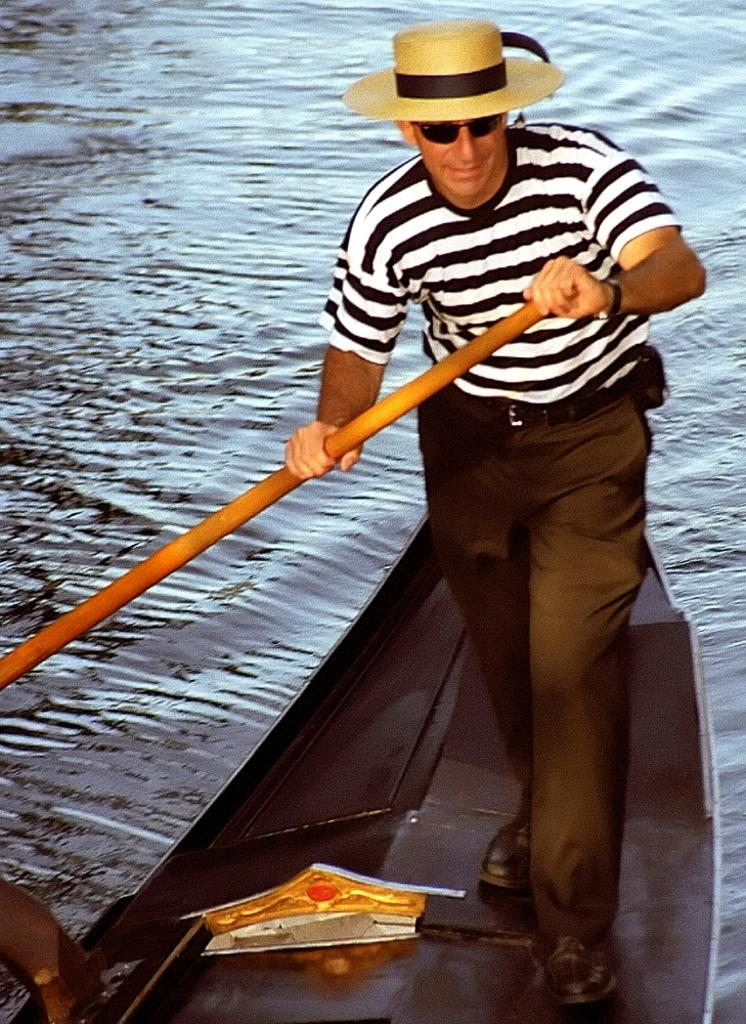What is the man in the image doing? The man is standing on a boat in the image. What is the man holding in the image? The man is holding a paddle in the image. What is the man wearing on his head? The man is wearing a hat in the image. What is the object in front of the man? There is an object in front of the man, but its specific nature is not clear from the provided facts. What can be seen in the background of the image? Water is visible in the image. What type of sand can be seen on the man's feet in the image? There is no sand visible in the image; the man is standing on a boat in water. What kind of apparatus is the man using to communicate with others in the image? There is no apparatus for communication visible in the image; the man is holding a paddle, which is used for propelling the boat. 